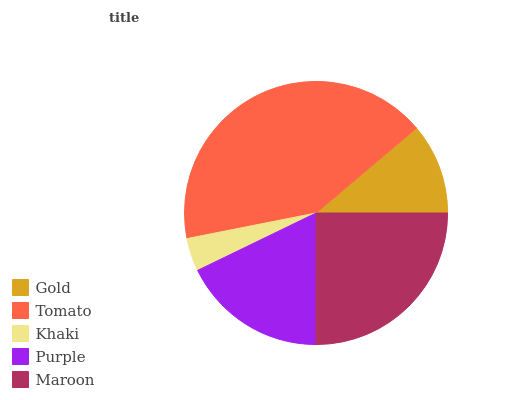Is Khaki the minimum?
Answer yes or no. Yes. Is Tomato the maximum?
Answer yes or no. Yes. Is Tomato the minimum?
Answer yes or no. No. Is Khaki the maximum?
Answer yes or no. No. Is Tomato greater than Khaki?
Answer yes or no. Yes. Is Khaki less than Tomato?
Answer yes or no. Yes. Is Khaki greater than Tomato?
Answer yes or no. No. Is Tomato less than Khaki?
Answer yes or no. No. Is Purple the high median?
Answer yes or no. Yes. Is Purple the low median?
Answer yes or no. Yes. Is Khaki the high median?
Answer yes or no. No. Is Maroon the low median?
Answer yes or no. No. 